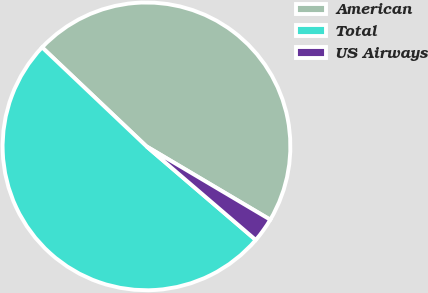<chart> <loc_0><loc_0><loc_500><loc_500><pie_chart><fcel>American<fcel>Total<fcel>US Airways<nl><fcel>46.43%<fcel>50.8%<fcel>2.76%<nl></chart> 